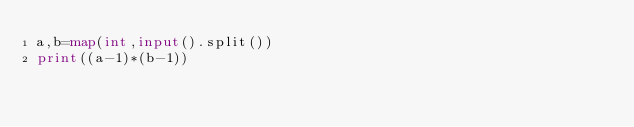<code> <loc_0><loc_0><loc_500><loc_500><_Python_>a,b=map(int,input().split())
print((a-1)*(b-1))
</code> 